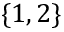<formula> <loc_0><loc_0><loc_500><loc_500>\{ 1 , 2 \}</formula> 